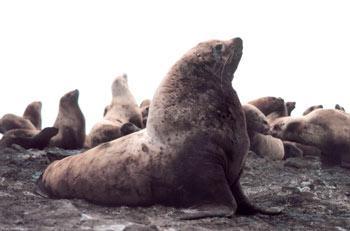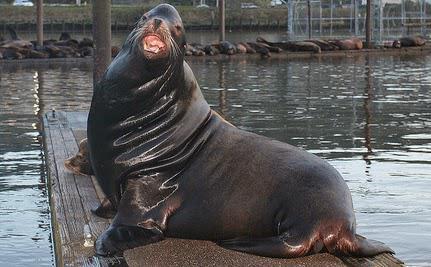The first image is the image on the left, the second image is the image on the right. For the images displayed, is the sentence "One of the sea lions in on sand." factually correct? Answer yes or no. No. The first image is the image on the left, the second image is the image on the right. Given the left and right images, does the statement "One of the images is of a lone animal on a sandy beach." hold true? Answer yes or no. No. 